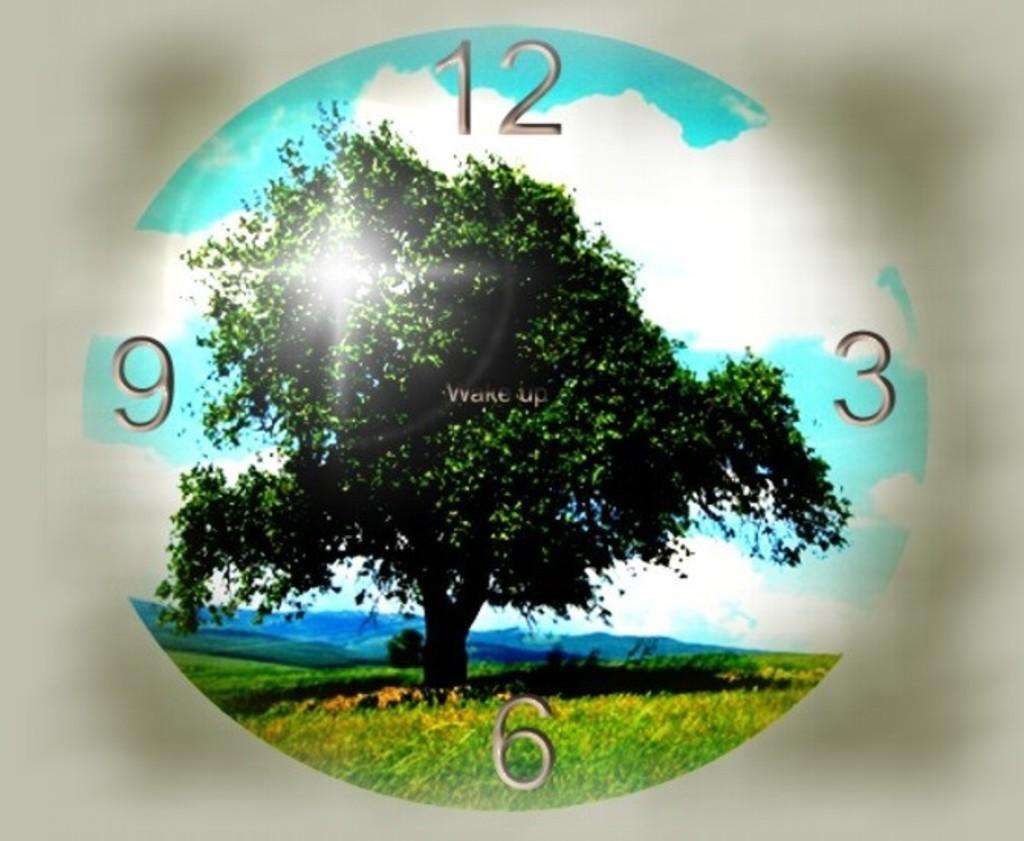What object in the image can be used to tell time? There is a clock in the image that can be used to tell time. What type of natural element is depicted in the image? There is an image of a tree in the image. What type of terrain is visible in the image? The ground with grass is visible in the image. What type of geographical feature can be seen in the distance? There are mountains in the image. What is visible in the sky in the image? The sky with clouds is visible in the image. What type of amusement can be seen in the image? There is no amusement present in the image; it features a clock, a tree, grass, mountains, and clouds. What type of industry is depicted in the image? There is no industry depicted in the image; it features a clock, a tree, grass, mountains, and clouds. 